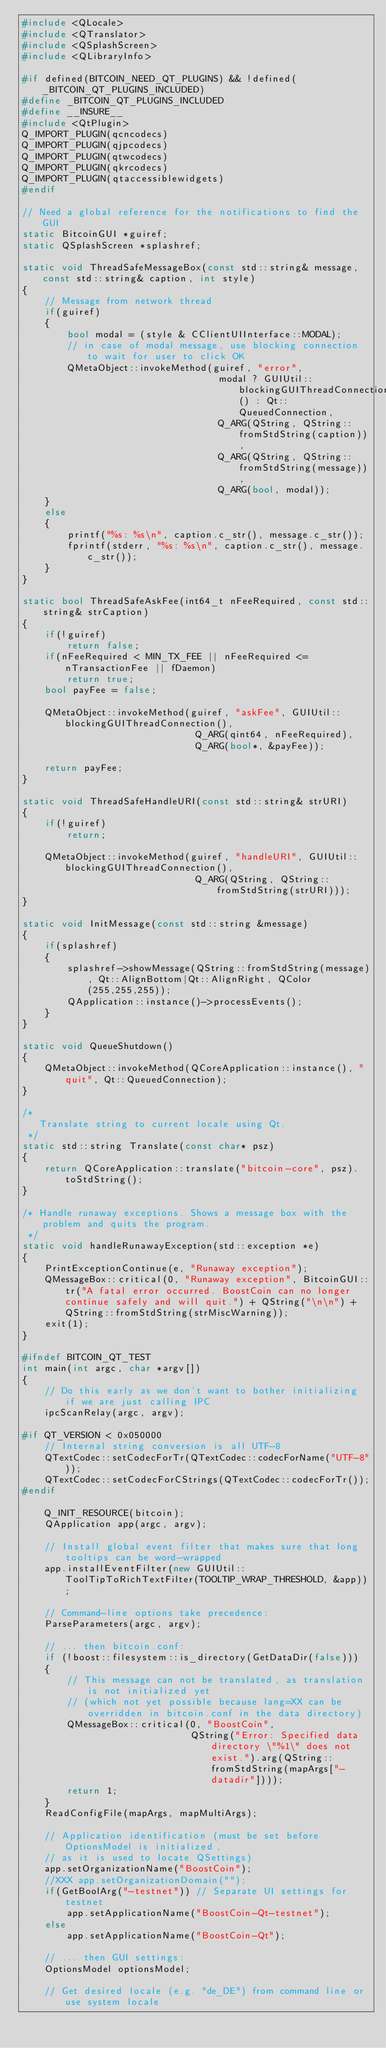<code> <loc_0><loc_0><loc_500><loc_500><_C++_>#include <QLocale>
#include <QTranslator>
#include <QSplashScreen>
#include <QLibraryInfo>

#if defined(BITCOIN_NEED_QT_PLUGINS) && !defined(_BITCOIN_QT_PLUGINS_INCLUDED)
#define _BITCOIN_QT_PLUGINS_INCLUDED
#define __INSURE__
#include <QtPlugin>
Q_IMPORT_PLUGIN(qcncodecs)
Q_IMPORT_PLUGIN(qjpcodecs)
Q_IMPORT_PLUGIN(qtwcodecs)
Q_IMPORT_PLUGIN(qkrcodecs)
Q_IMPORT_PLUGIN(qtaccessiblewidgets)
#endif

// Need a global reference for the notifications to find the GUI
static BitcoinGUI *guiref;
static QSplashScreen *splashref;

static void ThreadSafeMessageBox(const std::string& message, const std::string& caption, int style)
{
    // Message from network thread
    if(guiref)
    {
        bool modal = (style & CClientUIInterface::MODAL);
        // in case of modal message, use blocking connection to wait for user to click OK
        QMetaObject::invokeMethod(guiref, "error",
                                   modal ? GUIUtil::blockingGUIThreadConnection() : Qt::QueuedConnection,
                                   Q_ARG(QString, QString::fromStdString(caption)),
                                   Q_ARG(QString, QString::fromStdString(message)),
                                   Q_ARG(bool, modal));
    }
    else
    {
        printf("%s: %s\n", caption.c_str(), message.c_str());
        fprintf(stderr, "%s: %s\n", caption.c_str(), message.c_str());
    }
}

static bool ThreadSafeAskFee(int64_t nFeeRequired, const std::string& strCaption)
{
    if(!guiref)
        return false;
    if(nFeeRequired < MIN_TX_FEE || nFeeRequired <= nTransactionFee || fDaemon)
        return true;
    bool payFee = false;

    QMetaObject::invokeMethod(guiref, "askFee", GUIUtil::blockingGUIThreadConnection(),
                               Q_ARG(qint64, nFeeRequired),
                               Q_ARG(bool*, &payFee));

    return payFee;
}

static void ThreadSafeHandleURI(const std::string& strURI)
{
    if(!guiref)
        return;

    QMetaObject::invokeMethod(guiref, "handleURI", GUIUtil::blockingGUIThreadConnection(),
                               Q_ARG(QString, QString::fromStdString(strURI)));
}

static void InitMessage(const std::string &message)
{
    if(splashref)
    {
        splashref->showMessage(QString::fromStdString(message), Qt::AlignBottom|Qt::AlignRight, QColor(255,255,255));
        QApplication::instance()->processEvents();
    }
}

static void QueueShutdown()
{
    QMetaObject::invokeMethod(QCoreApplication::instance(), "quit", Qt::QueuedConnection);
}

/*
   Translate string to current locale using Qt.
 */
static std::string Translate(const char* psz)
{
    return QCoreApplication::translate("bitcoin-core", psz).toStdString();
}

/* Handle runaway exceptions. Shows a message box with the problem and quits the program.
 */
static void handleRunawayException(std::exception *e)
{
    PrintExceptionContinue(e, "Runaway exception");
    QMessageBox::critical(0, "Runaway exception", BitcoinGUI::tr("A fatal error occurred. BoostCoin can no longer continue safely and will quit.") + QString("\n\n") + QString::fromStdString(strMiscWarning));
    exit(1);
}

#ifndef BITCOIN_QT_TEST
int main(int argc, char *argv[])
{
    // Do this early as we don't want to bother initializing if we are just calling IPC
    ipcScanRelay(argc, argv);

#if QT_VERSION < 0x050000
    // Internal string conversion is all UTF-8
    QTextCodec::setCodecForTr(QTextCodec::codecForName("UTF-8"));
    QTextCodec::setCodecForCStrings(QTextCodec::codecForTr());
#endif

    Q_INIT_RESOURCE(bitcoin);
    QApplication app(argc, argv);

    // Install global event filter that makes sure that long tooltips can be word-wrapped
    app.installEventFilter(new GUIUtil::ToolTipToRichTextFilter(TOOLTIP_WRAP_THRESHOLD, &app));

    // Command-line options take precedence:
    ParseParameters(argc, argv);

    // ... then bitcoin.conf:
    if (!boost::filesystem::is_directory(GetDataDir(false)))
    {
        // This message can not be translated, as translation is not initialized yet
        // (which not yet possible because lang=XX can be overridden in bitcoin.conf in the data directory)
        QMessageBox::critical(0, "BoostCoin",
                              QString("Error: Specified data directory \"%1\" does not exist.").arg(QString::fromStdString(mapArgs["-datadir"])));
        return 1;
    }
    ReadConfigFile(mapArgs, mapMultiArgs);

    // Application identification (must be set before OptionsModel is initialized,
    // as it is used to locate QSettings)
    app.setOrganizationName("BoostCoin");
    //XXX app.setOrganizationDomain("");
    if(GetBoolArg("-testnet")) // Separate UI settings for testnet
        app.setApplicationName("BoostCoin-Qt-testnet");
    else
        app.setApplicationName("BoostCoin-Qt");

    // ... then GUI settings:
    OptionsModel optionsModel;

    // Get desired locale (e.g. "de_DE") from command line or use system locale</code> 